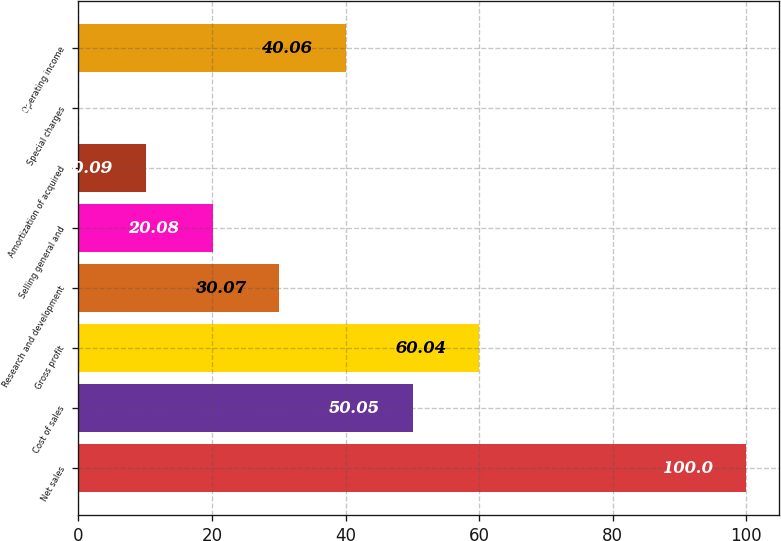<chart> <loc_0><loc_0><loc_500><loc_500><bar_chart><fcel>Net sales<fcel>Cost of sales<fcel>Gross profit<fcel>Research and development<fcel>Selling general and<fcel>Amortization of acquired<fcel>Special charges<fcel>Operating income<nl><fcel>100<fcel>50.05<fcel>60.04<fcel>30.07<fcel>20.08<fcel>10.09<fcel>0.1<fcel>40.06<nl></chart> 